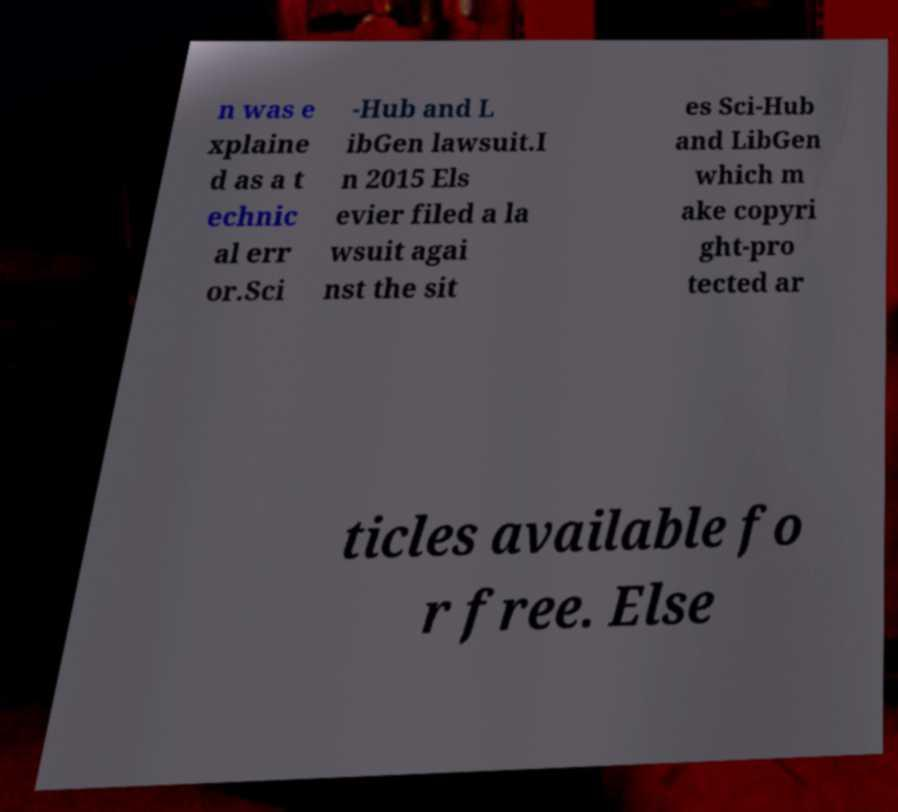There's text embedded in this image that I need extracted. Can you transcribe it verbatim? n was e xplaine d as a t echnic al err or.Sci -Hub and L ibGen lawsuit.I n 2015 Els evier filed a la wsuit agai nst the sit es Sci-Hub and LibGen which m ake copyri ght-pro tected ar ticles available fo r free. Else 